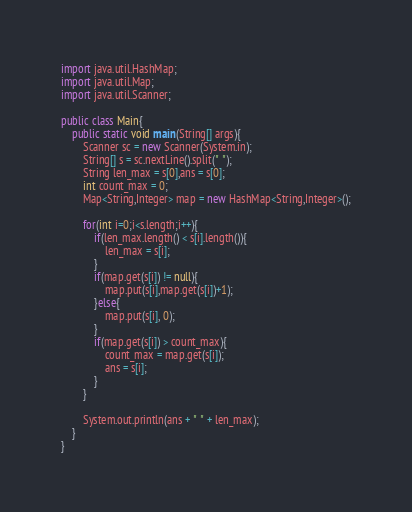<code> <loc_0><loc_0><loc_500><loc_500><_Java_>import java.util.HashMap;
import java.util.Map;
import java.util.Scanner;

public class Main{
	public static void main(String[] args){
		Scanner sc = new Scanner(System.in);
		String[] s = sc.nextLine().split(" ");
		String len_max = s[0],ans = s[0];
		int count_max = 0;
		Map<String,Integer> map = new HashMap<String,Integer>();
		
		for(int i=0;i<s.length;i++){
			if(len_max.length() < s[i].length()){
				len_max = s[i];
			}
			if(map.get(s[i]) != null){
				map.put(s[i],map.get(s[i])+1);
			}else{
				map.put(s[i], 0);
			}
			if(map.get(s[i]) > count_max){
				count_max = map.get(s[i]);
				ans = s[i];
			}
		}
		
		System.out.println(ans + " " + len_max);
	}
}</code> 